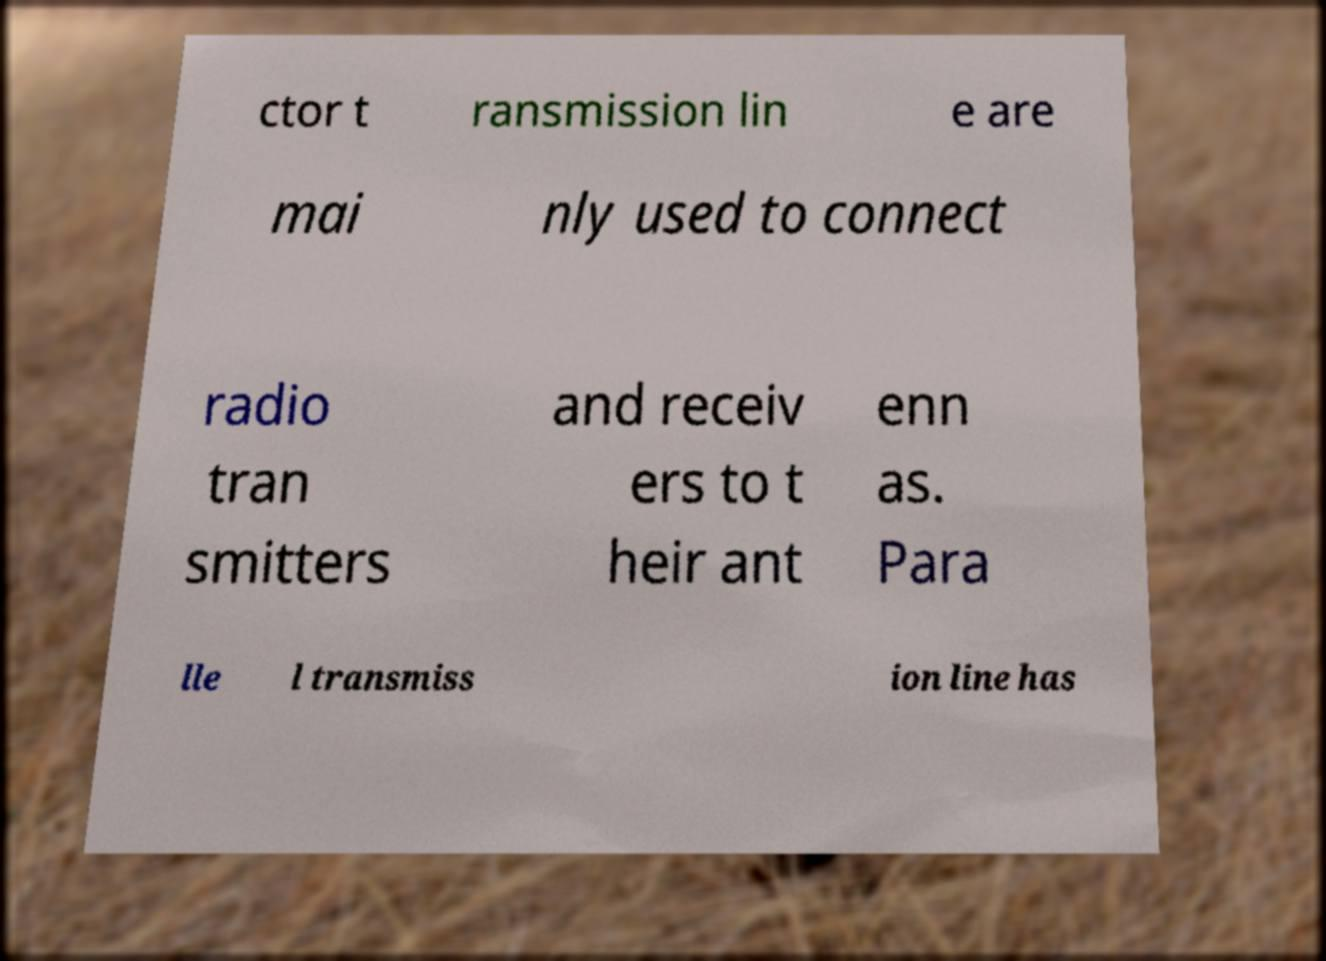Please read and relay the text visible in this image. What does it say? ctor t ransmission lin e are mai nly used to connect radio tran smitters and receiv ers to t heir ant enn as. Para lle l transmiss ion line has 